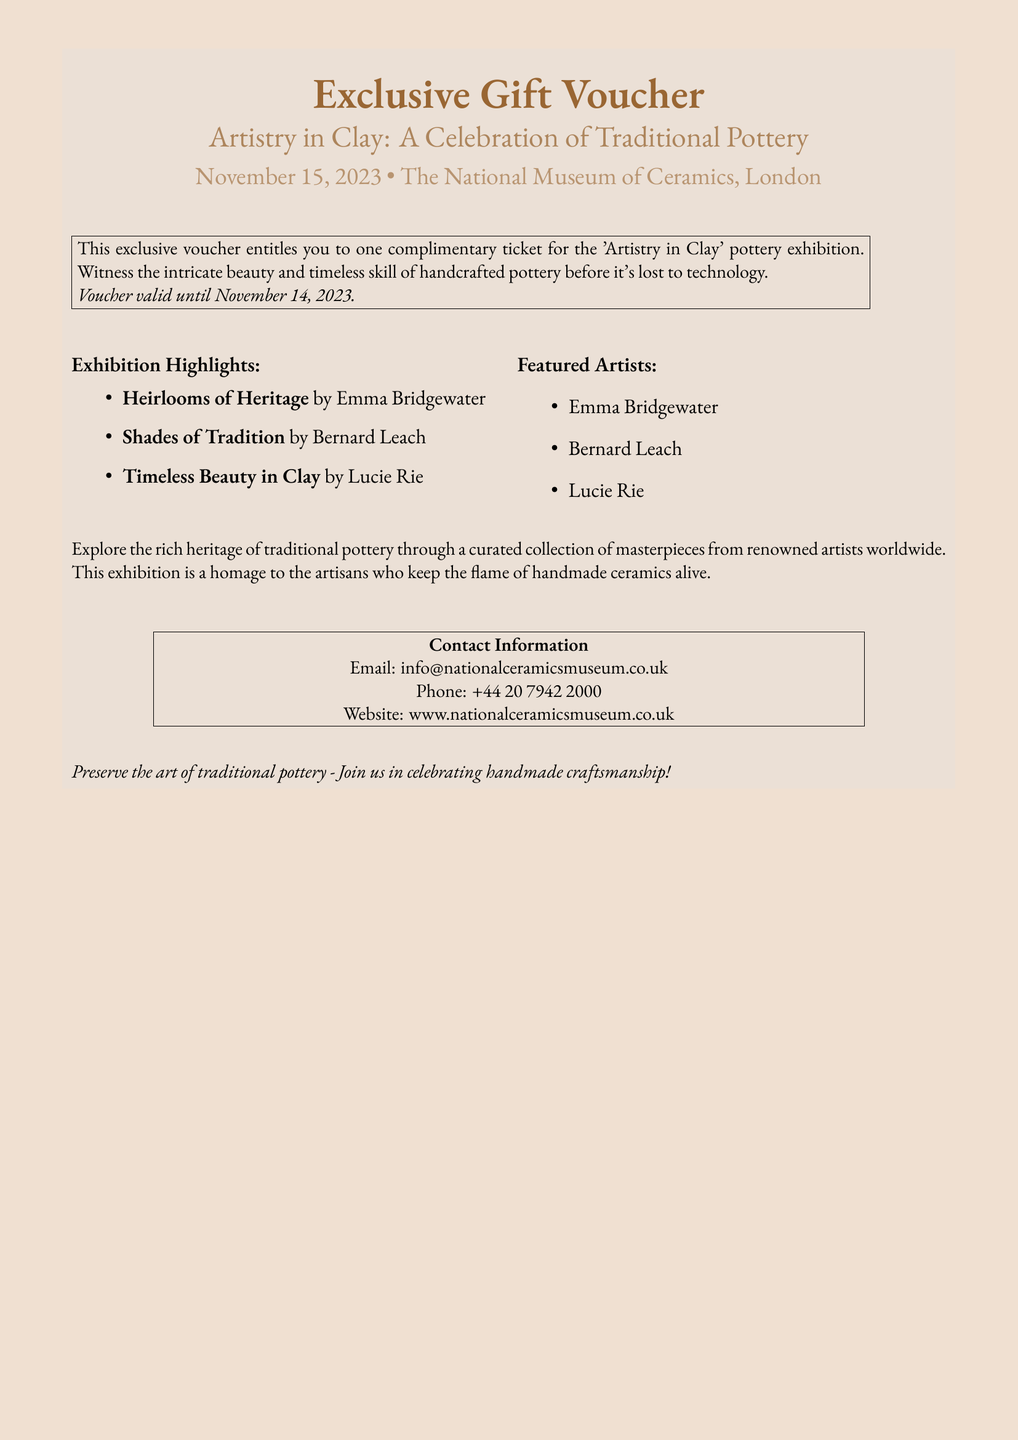What is the title of the exhibition? The title of the exhibition is found in the highlighted section at the top of the document.
Answer: Artistry in Clay: A Celebration of Traditional Pottery When is the exhibition taking place? The date of the exhibition is mentioned shortly after the title in the document.
Answer: November 15, 2023 Where is the exhibition held? The location of the exhibition is indicated right below the date in the document.
Answer: The National Museum of Ceramics, London Who is the featured artist of "Heirlooms of Heritage"? This information is listed under the exhibition highlights section in the document.
Answer: Emma Bridgewater How many artists are featured in the exhibition? The number of featured artists can be determined by counting the items in the "Featured Artists" list.
Answer: Three What is the deadline for using the voucher? The voucher validity date is stated explicitly in the document.
Answer: November 14, 2023 What type of ticket does the voucher provide? The type of ticket offered through the voucher is described in the document.
Answer: Complimentary ticket What is the exhibition a homage to? This reasoning question combines insight from the description of the exhibition found in the document.
Answer: Artisans who keep the flame of handmade ceramics alive 